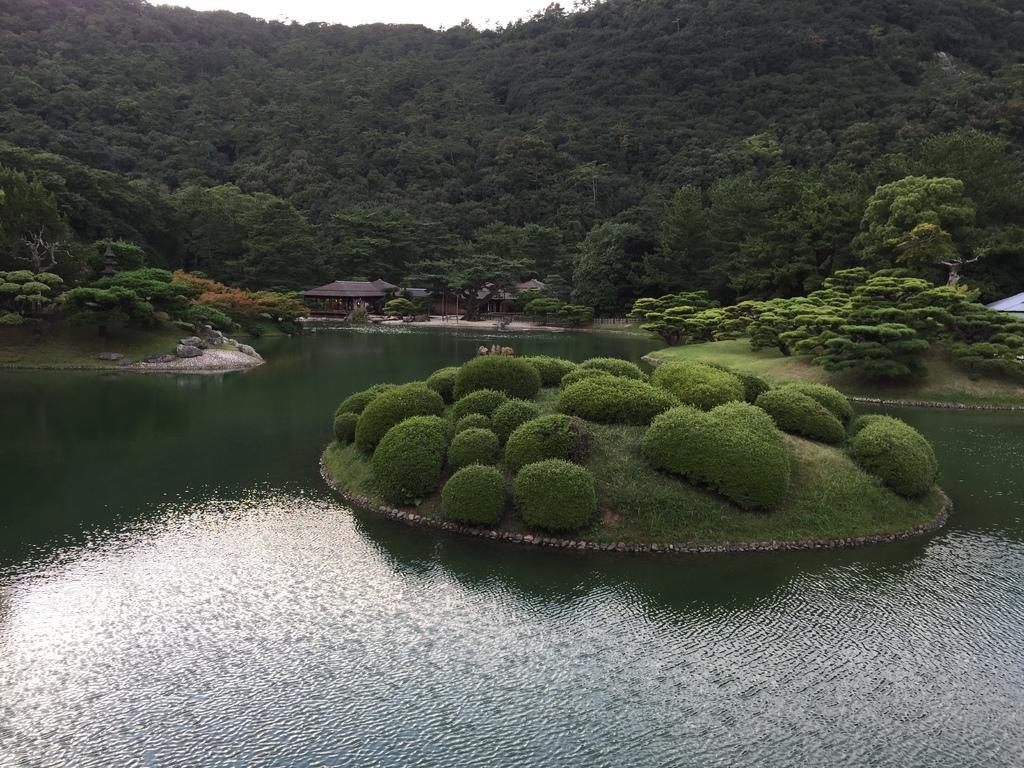Please provide a concise description of this image. In this image, we can see hills, trees, sheds and hedges. At the bottom, there is water. 